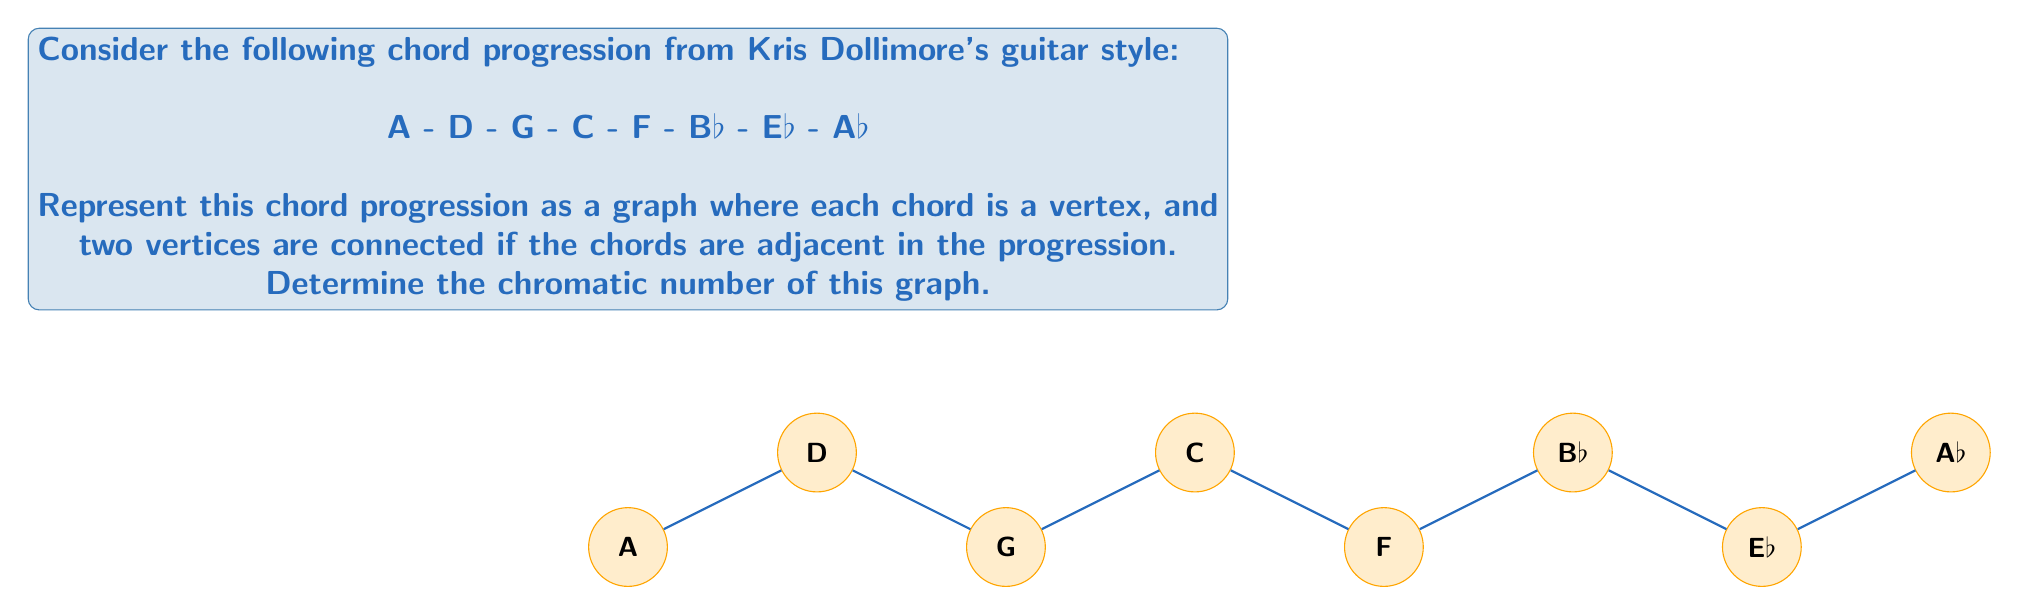Solve this math problem. To determine the chromatic number of this graph, we need to follow these steps:

1) First, let's understand what the graph represents:
   - Each vertex represents a chord in the progression.
   - Edges connect chords that are played consecutively.

2) The graph is a simple path with 8 vertices.

3) For a path graph, we can use the following theorem:
   The chromatic number of a path graph with $n$ vertices is:
   $$\chi(P_n) = \begin{cases} 
   2 & \text{if } n > 1 \\
   1 & \text{if } n = 1
   \end{cases}$$

4) In this case, we have 8 vertices $(n = 8)$, which is greater than 1.

5) Therefore, the chromatic number of this graph is 2.

This means we can color all the vertices using just two colors, alternating between them along the path. For example:
- Color 1: A, G, F, Eb
- Color 2: D, C, Bb, Ab

No two adjacent vertices (consecutive chords) will have the same color, satisfying the definition of proper graph coloring.
Answer: 2 